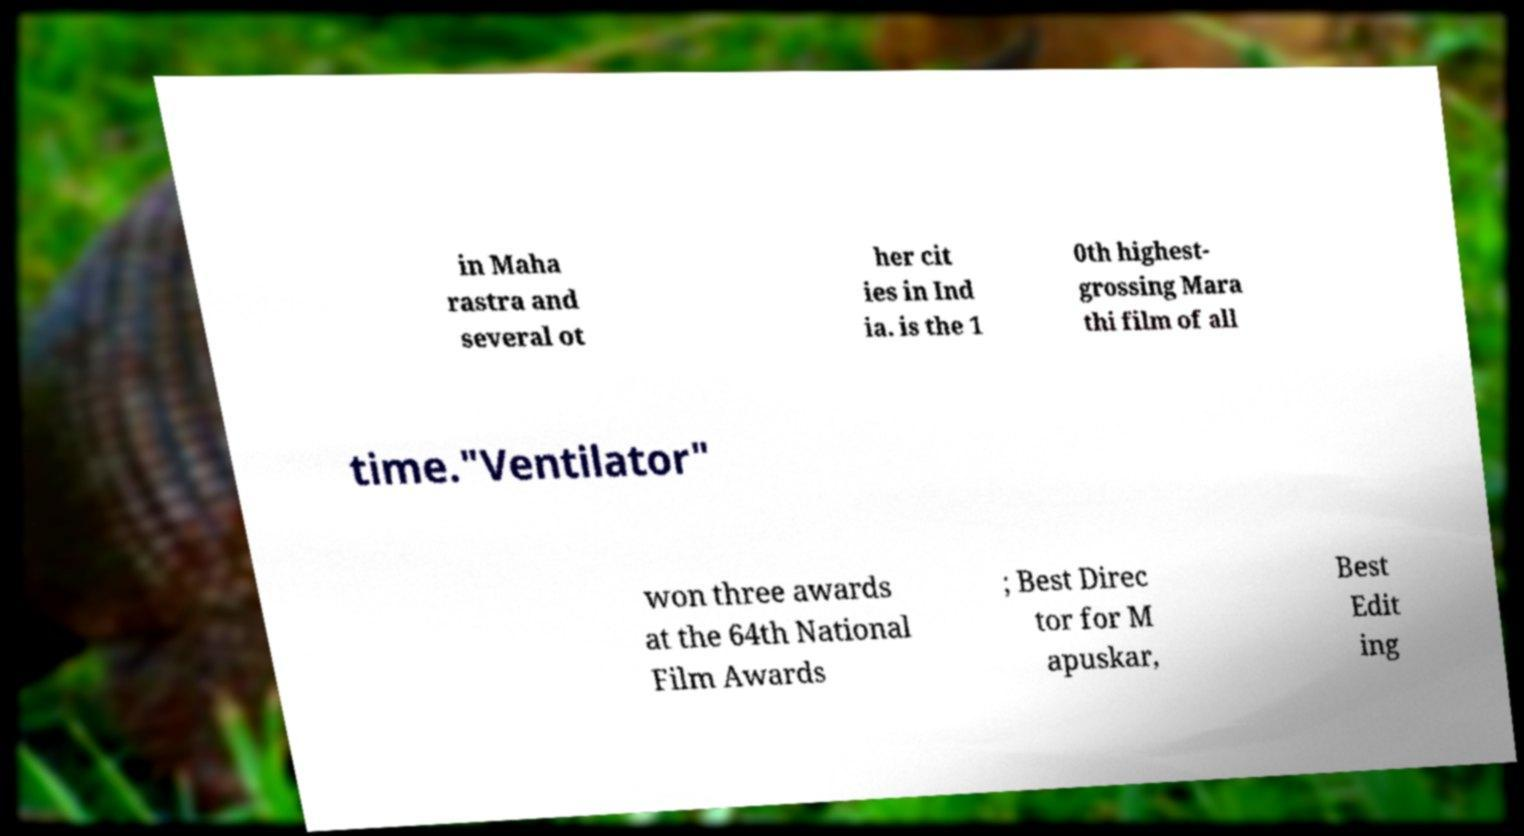Please identify and transcribe the text found in this image. in Maha rastra and several ot her cit ies in Ind ia. is the 1 0th highest- grossing Mara thi film of all time."Ventilator" won three awards at the 64th National Film Awards ; Best Direc tor for M apuskar, Best Edit ing 